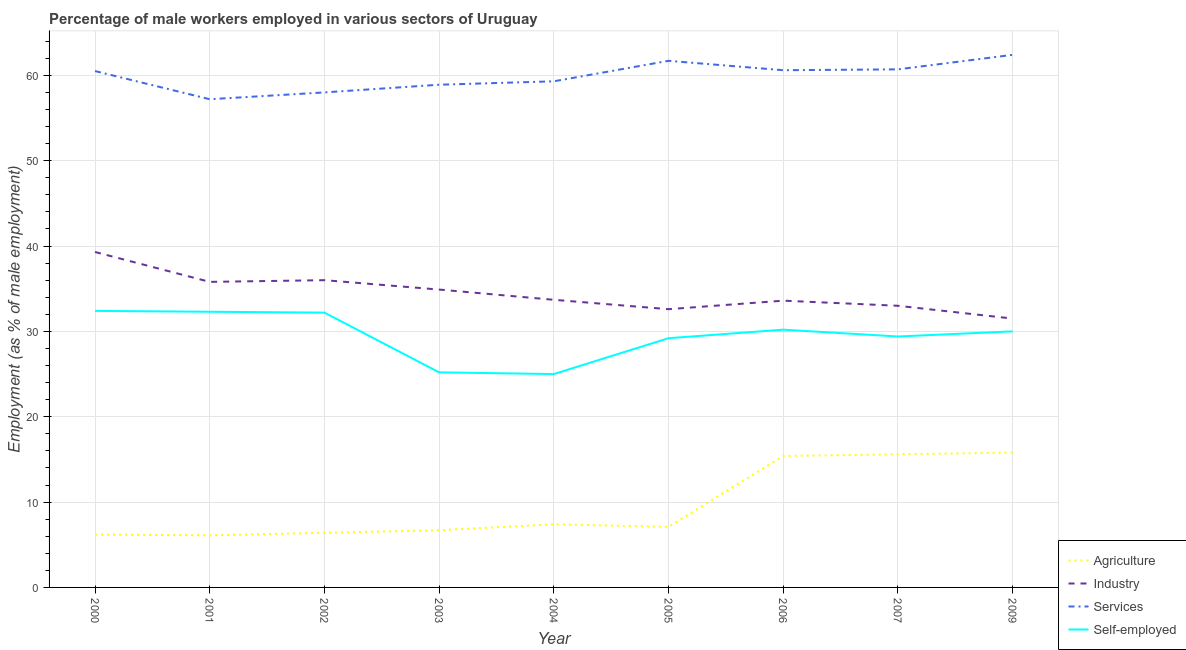Does the line corresponding to percentage of male workers in industry intersect with the line corresponding to percentage of male workers in agriculture?
Your response must be concise. No. Is the number of lines equal to the number of legend labels?
Make the answer very short. Yes. What is the percentage of male workers in services in 2001?
Keep it short and to the point. 57.2. Across all years, what is the maximum percentage of self employed male workers?
Offer a very short reply. 32.4. Across all years, what is the minimum percentage of male workers in services?
Keep it short and to the point. 57.2. In which year was the percentage of self employed male workers minimum?
Your answer should be compact. 2004. What is the total percentage of self employed male workers in the graph?
Offer a very short reply. 265.9. What is the difference between the percentage of self employed male workers in 2001 and that in 2003?
Give a very brief answer. 7.1. What is the difference between the percentage of self employed male workers in 2000 and the percentage of male workers in industry in 2004?
Offer a terse response. -1.3. What is the average percentage of male workers in agriculture per year?
Your answer should be compact. 9.63. In the year 2006, what is the difference between the percentage of self employed male workers and percentage of male workers in agriculture?
Make the answer very short. 14.8. In how many years, is the percentage of male workers in services greater than 30 %?
Give a very brief answer. 9. What is the ratio of the percentage of male workers in services in 2003 to that in 2009?
Provide a short and direct response. 0.94. Is the percentage of self employed male workers in 2002 less than that in 2006?
Provide a short and direct response. No. What is the difference between the highest and the second highest percentage of male workers in industry?
Your answer should be very brief. 3.3. What is the difference between the highest and the lowest percentage of male workers in industry?
Provide a succinct answer. 7.8. In how many years, is the percentage of male workers in industry greater than the average percentage of male workers in industry taken over all years?
Provide a short and direct response. 4. Is it the case that in every year, the sum of the percentage of male workers in agriculture and percentage of male workers in industry is greater than the percentage of male workers in services?
Your response must be concise. No. Does the percentage of male workers in agriculture monotonically increase over the years?
Your answer should be compact. No. Is the percentage of self employed male workers strictly greater than the percentage of male workers in services over the years?
Your response must be concise. No. Is the percentage of male workers in agriculture strictly less than the percentage of male workers in industry over the years?
Keep it short and to the point. Yes. Are the values on the major ticks of Y-axis written in scientific E-notation?
Give a very brief answer. No. Does the graph contain any zero values?
Your answer should be very brief. No. Does the graph contain grids?
Your answer should be compact. Yes. Where does the legend appear in the graph?
Offer a terse response. Bottom right. How many legend labels are there?
Give a very brief answer. 4. What is the title of the graph?
Offer a terse response. Percentage of male workers employed in various sectors of Uruguay. What is the label or title of the X-axis?
Your answer should be compact. Year. What is the label or title of the Y-axis?
Offer a terse response. Employment (as % of male employment). What is the Employment (as % of male employment) in Agriculture in 2000?
Offer a terse response. 6.2. What is the Employment (as % of male employment) in Industry in 2000?
Keep it short and to the point. 39.3. What is the Employment (as % of male employment) of Services in 2000?
Offer a terse response. 60.5. What is the Employment (as % of male employment) in Self-employed in 2000?
Your response must be concise. 32.4. What is the Employment (as % of male employment) of Agriculture in 2001?
Provide a short and direct response. 6.1. What is the Employment (as % of male employment) in Industry in 2001?
Give a very brief answer. 35.8. What is the Employment (as % of male employment) of Services in 2001?
Provide a succinct answer. 57.2. What is the Employment (as % of male employment) of Self-employed in 2001?
Offer a terse response. 32.3. What is the Employment (as % of male employment) in Agriculture in 2002?
Make the answer very short. 6.4. What is the Employment (as % of male employment) in Industry in 2002?
Keep it short and to the point. 36. What is the Employment (as % of male employment) in Self-employed in 2002?
Provide a succinct answer. 32.2. What is the Employment (as % of male employment) in Agriculture in 2003?
Keep it short and to the point. 6.7. What is the Employment (as % of male employment) in Industry in 2003?
Your answer should be compact. 34.9. What is the Employment (as % of male employment) in Services in 2003?
Provide a succinct answer. 58.9. What is the Employment (as % of male employment) of Self-employed in 2003?
Your response must be concise. 25.2. What is the Employment (as % of male employment) in Agriculture in 2004?
Provide a succinct answer. 7.4. What is the Employment (as % of male employment) in Industry in 2004?
Your answer should be compact. 33.7. What is the Employment (as % of male employment) of Services in 2004?
Provide a short and direct response. 59.3. What is the Employment (as % of male employment) of Agriculture in 2005?
Give a very brief answer. 7.1. What is the Employment (as % of male employment) in Industry in 2005?
Your response must be concise. 32.6. What is the Employment (as % of male employment) of Services in 2005?
Provide a succinct answer. 61.7. What is the Employment (as % of male employment) in Self-employed in 2005?
Your answer should be compact. 29.2. What is the Employment (as % of male employment) in Agriculture in 2006?
Your answer should be compact. 15.4. What is the Employment (as % of male employment) of Industry in 2006?
Offer a terse response. 33.6. What is the Employment (as % of male employment) in Services in 2006?
Provide a short and direct response. 60.6. What is the Employment (as % of male employment) in Self-employed in 2006?
Your response must be concise. 30.2. What is the Employment (as % of male employment) of Agriculture in 2007?
Provide a short and direct response. 15.6. What is the Employment (as % of male employment) of Services in 2007?
Your answer should be very brief. 60.7. What is the Employment (as % of male employment) of Self-employed in 2007?
Make the answer very short. 29.4. What is the Employment (as % of male employment) of Agriculture in 2009?
Give a very brief answer. 15.8. What is the Employment (as % of male employment) in Industry in 2009?
Offer a very short reply. 31.5. What is the Employment (as % of male employment) in Services in 2009?
Make the answer very short. 62.4. What is the Employment (as % of male employment) of Self-employed in 2009?
Make the answer very short. 30. Across all years, what is the maximum Employment (as % of male employment) of Agriculture?
Make the answer very short. 15.8. Across all years, what is the maximum Employment (as % of male employment) in Industry?
Provide a short and direct response. 39.3. Across all years, what is the maximum Employment (as % of male employment) in Services?
Offer a terse response. 62.4. Across all years, what is the maximum Employment (as % of male employment) in Self-employed?
Ensure brevity in your answer.  32.4. Across all years, what is the minimum Employment (as % of male employment) in Agriculture?
Your response must be concise. 6.1. Across all years, what is the minimum Employment (as % of male employment) in Industry?
Your response must be concise. 31.5. Across all years, what is the minimum Employment (as % of male employment) of Services?
Ensure brevity in your answer.  57.2. What is the total Employment (as % of male employment) of Agriculture in the graph?
Give a very brief answer. 86.7. What is the total Employment (as % of male employment) of Industry in the graph?
Make the answer very short. 310.4. What is the total Employment (as % of male employment) of Services in the graph?
Provide a short and direct response. 539.3. What is the total Employment (as % of male employment) of Self-employed in the graph?
Your answer should be very brief. 265.9. What is the difference between the Employment (as % of male employment) of Agriculture in 2000 and that in 2001?
Offer a very short reply. 0.1. What is the difference between the Employment (as % of male employment) of Self-employed in 2000 and that in 2001?
Offer a very short reply. 0.1. What is the difference between the Employment (as % of male employment) in Services in 2000 and that in 2002?
Offer a terse response. 2.5. What is the difference between the Employment (as % of male employment) of Self-employed in 2000 and that in 2002?
Give a very brief answer. 0.2. What is the difference between the Employment (as % of male employment) of Agriculture in 2000 and that in 2003?
Your answer should be very brief. -0.5. What is the difference between the Employment (as % of male employment) of Industry in 2000 and that in 2003?
Offer a very short reply. 4.4. What is the difference between the Employment (as % of male employment) of Self-employed in 2000 and that in 2003?
Your answer should be very brief. 7.2. What is the difference between the Employment (as % of male employment) in Services in 2000 and that in 2004?
Make the answer very short. 1.2. What is the difference between the Employment (as % of male employment) in Agriculture in 2000 and that in 2005?
Ensure brevity in your answer.  -0.9. What is the difference between the Employment (as % of male employment) in Industry in 2000 and that in 2005?
Give a very brief answer. 6.7. What is the difference between the Employment (as % of male employment) of Services in 2000 and that in 2005?
Your answer should be compact. -1.2. What is the difference between the Employment (as % of male employment) in Self-employed in 2000 and that in 2005?
Provide a succinct answer. 3.2. What is the difference between the Employment (as % of male employment) of Services in 2000 and that in 2006?
Make the answer very short. -0.1. What is the difference between the Employment (as % of male employment) of Self-employed in 2000 and that in 2006?
Your answer should be compact. 2.2. What is the difference between the Employment (as % of male employment) of Agriculture in 2000 and that in 2007?
Offer a terse response. -9.4. What is the difference between the Employment (as % of male employment) of Services in 2000 and that in 2007?
Provide a succinct answer. -0.2. What is the difference between the Employment (as % of male employment) in Self-employed in 2000 and that in 2007?
Your response must be concise. 3. What is the difference between the Employment (as % of male employment) in Agriculture in 2000 and that in 2009?
Ensure brevity in your answer.  -9.6. What is the difference between the Employment (as % of male employment) in Industry in 2000 and that in 2009?
Your answer should be very brief. 7.8. What is the difference between the Employment (as % of male employment) in Services in 2000 and that in 2009?
Your answer should be compact. -1.9. What is the difference between the Employment (as % of male employment) of Self-employed in 2000 and that in 2009?
Your answer should be compact. 2.4. What is the difference between the Employment (as % of male employment) in Agriculture in 2001 and that in 2002?
Offer a terse response. -0.3. What is the difference between the Employment (as % of male employment) in Services in 2001 and that in 2002?
Your answer should be very brief. -0.8. What is the difference between the Employment (as % of male employment) in Agriculture in 2001 and that in 2003?
Offer a very short reply. -0.6. What is the difference between the Employment (as % of male employment) in Industry in 2001 and that in 2003?
Keep it short and to the point. 0.9. What is the difference between the Employment (as % of male employment) in Services in 2001 and that in 2003?
Ensure brevity in your answer.  -1.7. What is the difference between the Employment (as % of male employment) in Services in 2001 and that in 2005?
Make the answer very short. -4.5. What is the difference between the Employment (as % of male employment) in Agriculture in 2001 and that in 2006?
Your answer should be compact. -9.3. What is the difference between the Employment (as % of male employment) of Agriculture in 2001 and that in 2007?
Provide a short and direct response. -9.5. What is the difference between the Employment (as % of male employment) in Industry in 2001 and that in 2007?
Keep it short and to the point. 2.8. What is the difference between the Employment (as % of male employment) of Services in 2001 and that in 2007?
Make the answer very short. -3.5. What is the difference between the Employment (as % of male employment) in Self-employed in 2001 and that in 2007?
Make the answer very short. 2.9. What is the difference between the Employment (as % of male employment) in Industry in 2001 and that in 2009?
Ensure brevity in your answer.  4.3. What is the difference between the Employment (as % of male employment) of Self-employed in 2002 and that in 2003?
Your answer should be compact. 7. What is the difference between the Employment (as % of male employment) of Industry in 2002 and that in 2004?
Offer a very short reply. 2.3. What is the difference between the Employment (as % of male employment) of Self-employed in 2002 and that in 2004?
Make the answer very short. 7.2. What is the difference between the Employment (as % of male employment) of Agriculture in 2002 and that in 2005?
Offer a very short reply. -0.7. What is the difference between the Employment (as % of male employment) of Industry in 2002 and that in 2005?
Give a very brief answer. 3.4. What is the difference between the Employment (as % of male employment) in Self-employed in 2002 and that in 2005?
Give a very brief answer. 3. What is the difference between the Employment (as % of male employment) in Agriculture in 2002 and that in 2006?
Give a very brief answer. -9. What is the difference between the Employment (as % of male employment) in Industry in 2002 and that in 2006?
Your response must be concise. 2.4. What is the difference between the Employment (as % of male employment) in Self-employed in 2002 and that in 2006?
Ensure brevity in your answer.  2. What is the difference between the Employment (as % of male employment) of Agriculture in 2002 and that in 2007?
Your answer should be compact. -9.2. What is the difference between the Employment (as % of male employment) of Industry in 2002 and that in 2007?
Offer a terse response. 3. What is the difference between the Employment (as % of male employment) of Services in 2002 and that in 2007?
Make the answer very short. -2.7. What is the difference between the Employment (as % of male employment) in Industry in 2002 and that in 2009?
Make the answer very short. 4.5. What is the difference between the Employment (as % of male employment) in Self-employed in 2002 and that in 2009?
Your response must be concise. 2.2. What is the difference between the Employment (as % of male employment) of Agriculture in 2003 and that in 2004?
Your answer should be very brief. -0.7. What is the difference between the Employment (as % of male employment) in Industry in 2003 and that in 2004?
Offer a terse response. 1.2. What is the difference between the Employment (as % of male employment) in Self-employed in 2003 and that in 2004?
Give a very brief answer. 0.2. What is the difference between the Employment (as % of male employment) in Industry in 2003 and that in 2005?
Offer a terse response. 2.3. What is the difference between the Employment (as % of male employment) of Self-employed in 2003 and that in 2005?
Offer a very short reply. -4. What is the difference between the Employment (as % of male employment) in Agriculture in 2003 and that in 2006?
Ensure brevity in your answer.  -8.7. What is the difference between the Employment (as % of male employment) of Industry in 2003 and that in 2006?
Make the answer very short. 1.3. What is the difference between the Employment (as % of male employment) of Services in 2003 and that in 2006?
Provide a succinct answer. -1.7. What is the difference between the Employment (as % of male employment) of Industry in 2003 and that in 2007?
Your answer should be compact. 1.9. What is the difference between the Employment (as % of male employment) in Self-employed in 2003 and that in 2009?
Provide a succinct answer. -4.8. What is the difference between the Employment (as % of male employment) in Agriculture in 2004 and that in 2005?
Offer a terse response. 0.3. What is the difference between the Employment (as % of male employment) in Industry in 2004 and that in 2005?
Offer a terse response. 1.1. What is the difference between the Employment (as % of male employment) in Services in 2004 and that in 2005?
Your response must be concise. -2.4. What is the difference between the Employment (as % of male employment) of Agriculture in 2004 and that in 2006?
Offer a terse response. -8. What is the difference between the Employment (as % of male employment) in Self-employed in 2004 and that in 2006?
Offer a very short reply. -5.2. What is the difference between the Employment (as % of male employment) in Industry in 2004 and that in 2007?
Offer a very short reply. 0.7. What is the difference between the Employment (as % of male employment) of Services in 2004 and that in 2007?
Provide a short and direct response. -1.4. What is the difference between the Employment (as % of male employment) in Services in 2004 and that in 2009?
Provide a short and direct response. -3.1. What is the difference between the Employment (as % of male employment) in Self-employed in 2004 and that in 2009?
Provide a short and direct response. -5. What is the difference between the Employment (as % of male employment) of Industry in 2005 and that in 2006?
Ensure brevity in your answer.  -1. What is the difference between the Employment (as % of male employment) of Services in 2005 and that in 2006?
Offer a terse response. 1.1. What is the difference between the Employment (as % of male employment) in Self-employed in 2005 and that in 2006?
Give a very brief answer. -1. What is the difference between the Employment (as % of male employment) of Agriculture in 2005 and that in 2007?
Ensure brevity in your answer.  -8.5. What is the difference between the Employment (as % of male employment) in Industry in 2005 and that in 2007?
Keep it short and to the point. -0.4. What is the difference between the Employment (as % of male employment) of Services in 2005 and that in 2009?
Your response must be concise. -0.7. What is the difference between the Employment (as % of male employment) of Self-employed in 2005 and that in 2009?
Give a very brief answer. -0.8. What is the difference between the Employment (as % of male employment) in Agriculture in 2006 and that in 2009?
Keep it short and to the point. -0.4. What is the difference between the Employment (as % of male employment) of Industry in 2006 and that in 2009?
Provide a succinct answer. 2.1. What is the difference between the Employment (as % of male employment) of Services in 2006 and that in 2009?
Make the answer very short. -1.8. What is the difference between the Employment (as % of male employment) in Industry in 2007 and that in 2009?
Provide a succinct answer. 1.5. What is the difference between the Employment (as % of male employment) in Self-employed in 2007 and that in 2009?
Ensure brevity in your answer.  -0.6. What is the difference between the Employment (as % of male employment) of Agriculture in 2000 and the Employment (as % of male employment) of Industry in 2001?
Your answer should be very brief. -29.6. What is the difference between the Employment (as % of male employment) in Agriculture in 2000 and the Employment (as % of male employment) in Services in 2001?
Provide a short and direct response. -51. What is the difference between the Employment (as % of male employment) in Agriculture in 2000 and the Employment (as % of male employment) in Self-employed in 2001?
Your answer should be compact. -26.1. What is the difference between the Employment (as % of male employment) in Industry in 2000 and the Employment (as % of male employment) in Services in 2001?
Offer a terse response. -17.9. What is the difference between the Employment (as % of male employment) in Services in 2000 and the Employment (as % of male employment) in Self-employed in 2001?
Provide a succinct answer. 28.2. What is the difference between the Employment (as % of male employment) of Agriculture in 2000 and the Employment (as % of male employment) of Industry in 2002?
Provide a short and direct response. -29.8. What is the difference between the Employment (as % of male employment) of Agriculture in 2000 and the Employment (as % of male employment) of Services in 2002?
Keep it short and to the point. -51.8. What is the difference between the Employment (as % of male employment) of Agriculture in 2000 and the Employment (as % of male employment) of Self-employed in 2002?
Provide a short and direct response. -26. What is the difference between the Employment (as % of male employment) of Industry in 2000 and the Employment (as % of male employment) of Services in 2002?
Offer a terse response. -18.7. What is the difference between the Employment (as % of male employment) in Services in 2000 and the Employment (as % of male employment) in Self-employed in 2002?
Ensure brevity in your answer.  28.3. What is the difference between the Employment (as % of male employment) in Agriculture in 2000 and the Employment (as % of male employment) in Industry in 2003?
Your response must be concise. -28.7. What is the difference between the Employment (as % of male employment) of Agriculture in 2000 and the Employment (as % of male employment) of Services in 2003?
Ensure brevity in your answer.  -52.7. What is the difference between the Employment (as % of male employment) in Industry in 2000 and the Employment (as % of male employment) in Services in 2003?
Your answer should be compact. -19.6. What is the difference between the Employment (as % of male employment) of Services in 2000 and the Employment (as % of male employment) of Self-employed in 2003?
Provide a succinct answer. 35.3. What is the difference between the Employment (as % of male employment) in Agriculture in 2000 and the Employment (as % of male employment) in Industry in 2004?
Give a very brief answer. -27.5. What is the difference between the Employment (as % of male employment) in Agriculture in 2000 and the Employment (as % of male employment) in Services in 2004?
Make the answer very short. -53.1. What is the difference between the Employment (as % of male employment) of Agriculture in 2000 and the Employment (as % of male employment) of Self-employed in 2004?
Your answer should be compact. -18.8. What is the difference between the Employment (as % of male employment) of Industry in 2000 and the Employment (as % of male employment) of Services in 2004?
Offer a very short reply. -20. What is the difference between the Employment (as % of male employment) of Industry in 2000 and the Employment (as % of male employment) of Self-employed in 2004?
Provide a succinct answer. 14.3. What is the difference between the Employment (as % of male employment) of Services in 2000 and the Employment (as % of male employment) of Self-employed in 2004?
Keep it short and to the point. 35.5. What is the difference between the Employment (as % of male employment) of Agriculture in 2000 and the Employment (as % of male employment) of Industry in 2005?
Keep it short and to the point. -26.4. What is the difference between the Employment (as % of male employment) in Agriculture in 2000 and the Employment (as % of male employment) in Services in 2005?
Your answer should be very brief. -55.5. What is the difference between the Employment (as % of male employment) of Agriculture in 2000 and the Employment (as % of male employment) of Self-employed in 2005?
Offer a very short reply. -23. What is the difference between the Employment (as % of male employment) in Industry in 2000 and the Employment (as % of male employment) in Services in 2005?
Offer a terse response. -22.4. What is the difference between the Employment (as % of male employment) in Services in 2000 and the Employment (as % of male employment) in Self-employed in 2005?
Offer a terse response. 31.3. What is the difference between the Employment (as % of male employment) of Agriculture in 2000 and the Employment (as % of male employment) of Industry in 2006?
Make the answer very short. -27.4. What is the difference between the Employment (as % of male employment) of Agriculture in 2000 and the Employment (as % of male employment) of Services in 2006?
Ensure brevity in your answer.  -54.4. What is the difference between the Employment (as % of male employment) of Industry in 2000 and the Employment (as % of male employment) of Services in 2006?
Your answer should be very brief. -21.3. What is the difference between the Employment (as % of male employment) of Services in 2000 and the Employment (as % of male employment) of Self-employed in 2006?
Provide a succinct answer. 30.3. What is the difference between the Employment (as % of male employment) of Agriculture in 2000 and the Employment (as % of male employment) of Industry in 2007?
Ensure brevity in your answer.  -26.8. What is the difference between the Employment (as % of male employment) in Agriculture in 2000 and the Employment (as % of male employment) in Services in 2007?
Offer a terse response. -54.5. What is the difference between the Employment (as % of male employment) in Agriculture in 2000 and the Employment (as % of male employment) in Self-employed in 2007?
Make the answer very short. -23.2. What is the difference between the Employment (as % of male employment) of Industry in 2000 and the Employment (as % of male employment) of Services in 2007?
Offer a very short reply. -21.4. What is the difference between the Employment (as % of male employment) in Services in 2000 and the Employment (as % of male employment) in Self-employed in 2007?
Offer a very short reply. 31.1. What is the difference between the Employment (as % of male employment) in Agriculture in 2000 and the Employment (as % of male employment) in Industry in 2009?
Make the answer very short. -25.3. What is the difference between the Employment (as % of male employment) of Agriculture in 2000 and the Employment (as % of male employment) of Services in 2009?
Keep it short and to the point. -56.2. What is the difference between the Employment (as % of male employment) in Agriculture in 2000 and the Employment (as % of male employment) in Self-employed in 2009?
Give a very brief answer. -23.8. What is the difference between the Employment (as % of male employment) in Industry in 2000 and the Employment (as % of male employment) in Services in 2009?
Your response must be concise. -23.1. What is the difference between the Employment (as % of male employment) in Services in 2000 and the Employment (as % of male employment) in Self-employed in 2009?
Keep it short and to the point. 30.5. What is the difference between the Employment (as % of male employment) of Agriculture in 2001 and the Employment (as % of male employment) of Industry in 2002?
Provide a short and direct response. -29.9. What is the difference between the Employment (as % of male employment) in Agriculture in 2001 and the Employment (as % of male employment) in Services in 2002?
Your answer should be very brief. -51.9. What is the difference between the Employment (as % of male employment) of Agriculture in 2001 and the Employment (as % of male employment) of Self-employed in 2002?
Ensure brevity in your answer.  -26.1. What is the difference between the Employment (as % of male employment) in Industry in 2001 and the Employment (as % of male employment) in Services in 2002?
Offer a very short reply. -22.2. What is the difference between the Employment (as % of male employment) of Services in 2001 and the Employment (as % of male employment) of Self-employed in 2002?
Your response must be concise. 25. What is the difference between the Employment (as % of male employment) in Agriculture in 2001 and the Employment (as % of male employment) in Industry in 2003?
Keep it short and to the point. -28.8. What is the difference between the Employment (as % of male employment) of Agriculture in 2001 and the Employment (as % of male employment) of Services in 2003?
Make the answer very short. -52.8. What is the difference between the Employment (as % of male employment) in Agriculture in 2001 and the Employment (as % of male employment) in Self-employed in 2003?
Offer a terse response. -19.1. What is the difference between the Employment (as % of male employment) of Industry in 2001 and the Employment (as % of male employment) of Services in 2003?
Make the answer very short. -23.1. What is the difference between the Employment (as % of male employment) of Industry in 2001 and the Employment (as % of male employment) of Self-employed in 2003?
Your response must be concise. 10.6. What is the difference between the Employment (as % of male employment) in Agriculture in 2001 and the Employment (as % of male employment) in Industry in 2004?
Offer a terse response. -27.6. What is the difference between the Employment (as % of male employment) of Agriculture in 2001 and the Employment (as % of male employment) of Services in 2004?
Your answer should be compact. -53.2. What is the difference between the Employment (as % of male employment) in Agriculture in 2001 and the Employment (as % of male employment) in Self-employed in 2004?
Offer a terse response. -18.9. What is the difference between the Employment (as % of male employment) of Industry in 2001 and the Employment (as % of male employment) of Services in 2004?
Ensure brevity in your answer.  -23.5. What is the difference between the Employment (as % of male employment) in Services in 2001 and the Employment (as % of male employment) in Self-employed in 2004?
Your answer should be very brief. 32.2. What is the difference between the Employment (as % of male employment) of Agriculture in 2001 and the Employment (as % of male employment) of Industry in 2005?
Provide a short and direct response. -26.5. What is the difference between the Employment (as % of male employment) of Agriculture in 2001 and the Employment (as % of male employment) of Services in 2005?
Your answer should be very brief. -55.6. What is the difference between the Employment (as % of male employment) of Agriculture in 2001 and the Employment (as % of male employment) of Self-employed in 2005?
Offer a terse response. -23.1. What is the difference between the Employment (as % of male employment) in Industry in 2001 and the Employment (as % of male employment) in Services in 2005?
Offer a very short reply. -25.9. What is the difference between the Employment (as % of male employment) of Services in 2001 and the Employment (as % of male employment) of Self-employed in 2005?
Offer a very short reply. 28. What is the difference between the Employment (as % of male employment) of Agriculture in 2001 and the Employment (as % of male employment) of Industry in 2006?
Give a very brief answer. -27.5. What is the difference between the Employment (as % of male employment) of Agriculture in 2001 and the Employment (as % of male employment) of Services in 2006?
Keep it short and to the point. -54.5. What is the difference between the Employment (as % of male employment) in Agriculture in 2001 and the Employment (as % of male employment) in Self-employed in 2006?
Your answer should be very brief. -24.1. What is the difference between the Employment (as % of male employment) in Industry in 2001 and the Employment (as % of male employment) in Services in 2006?
Offer a very short reply. -24.8. What is the difference between the Employment (as % of male employment) in Services in 2001 and the Employment (as % of male employment) in Self-employed in 2006?
Offer a terse response. 27. What is the difference between the Employment (as % of male employment) in Agriculture in 2001 and the Employment (as % of male employment) in Industry in 2007?
Your answer should be compact. -26.9. What is the difference between the Employment (as % of male employment) in Agriculture in 2001 and the Employment (as % of male employment) in Services in 2007?
Provide a short and direct response. -54.6. What is the difference between the Employment (as % of male employment) in Agriculture in 2001 and the Employment (as % of male employment) in Self-employed in 2007?
Your answer should be compact. -23.3. What is the difference between the Employment (as % of male employment) in Industry in 2001 and the Employment (as % of male employment) in Services in 2007?
Give a very brief answer. -24.9. What is the difference between the Employment (as % of male employment) in Industry in 2001 and the Employment (as % of male employment) in Self-employed in 2007?
Make the answer very short. 6.4. What is the difference between the Employment (as % of male employment) in Services in 2001 and the Employment (as % of male employment) in Self-employed in 2007?
Offer a terse response. 27.8. What is the difference between the Employment (as % of male employment) of Agriculture in 2001 and the Employment (as % of male employment) of Industry in 2009?
Your response must be concise. -25.4. What is the difference between the Employment (as % of male employment) of Agriculture in 2001 and the Employment (as % of male employment) of Services in 2009?
Keep it short and to the point. -56.3. What is the difference between the Employment (as % of male employment) of Agriculture in 2001 and the Employment (as % of male employment) of Self-employed in 2009?
Keep it short and to the point. -23.9. What is the difference between the Employment (as % of male employment) of Industry in 2001 and the Employment (as % of male employment) of Services in 2009?
Your response must be concise. -26.6. What is the difference between the Employment (as % of male employment) in Industry in 2001 and the Employment (as % of male employment) in Self-employed in 2009?
Provide a short and direct response. 5.8. What is the difference between the Employment (as % of male employment) of Services in 2001 and the Employment (as % of male employment) of Self-employed in 2009?
Give a very brief answer. 27.2. What is the difference between the Employment (as % of male employment) in Agriculture in 2002 and the Employment (as % of male employment) in Industry in 2003?
Ensure brevity in your answer.  -28.5. What is the difference between the Employment (as % of male employment) in Agriculture in 2002 and the Employment (as % of male employment) in Services in 2003?
Your answer should be compact. -52.5. What is the difference between the Employment (as % of male employment) in Agriculture in 2002 and the Employment (as % of male employment) in Self-employed in 2003?
Provide a short and direct response. -18.8. What is the difference between the Employment (as % of male employment) of Industry in 2002 and the Employment (as % of male employment) of Services in 2003?
Ensure brevity in your answer.  -22.9. What is the difference between the Employment (as % of male employment) in Services in 2002 and the Employment (as % of male employment) in Self-employed in 2003?
Provide a short and direct response. 32.8. What is the difference between the Employment (as % of male employment) in Agriculture in 2002 and the Employment (as % of male employment) in Industry in 2004?
Your answer should be compact. -27.3. What is the difference between the Employment (as % of male employment) of Agriculture in 2002 and the Employment (as % of male employment) of Services in 2004?
Keep it short and to the point. -52.9. What is the difference between the Employment (as % of male employment) in Agriculture in 2002 and the Employment (as % of male employment) in Self-employed in 2004?
Offer a terse response. -18.6. What is the difference between the Employment (as % of male employment) in Industry in 2002 and the Employment (as % of male employment) in Services in 2004?
Ensure brevity in your answer.  -23.3. What is the difference between the Employment (as % of male employment) of Services in 2002 and the Employment (as % of male employment) of Self-employed in 2004?
Give a very brief answer. 33. What is the difference between the Employment (as % of male employment) in Agriculture in 2002 and the Employment (as % of male employment) in Industry in 2005?
Provide a short and direct response. -26.2. What is the difference between the Employment (as % of male employment) in Agriculture in 2002 and the Employment (as % of male employment) in Services in 2005?
Your answer should be compact. -55.3. What is the difference between the Employment (as % of male employment) of Agriculture in 2002 and the Employment (as % of male employment) of Self-employed in 2005?
Give a very brief answer. -22.8. What is the difference between the Employment (as % of male employment) of Industry in 2002 and the Employment (as % of male employment) of Services in 2005?
Keep it short and to the point. -25.7. What is the difference between the Employment (as % of male employment) in Services in 2002 and the Employment (as % of male employment) in Self-employed in 2005?
Make the answer very short. 28.8. What is the difference between the Employment (as % of male employment) in Agriculture in 2002 and the Employment (as % of male employment) in Industry in 2006?
Offer a terse response. -27.2. What is the difference between the Employment (as % of male employment) of Agriculture in 2002 and the Employment (as % of male employment) of Services in 2006?
Your answer should be very brief. -54.2. What is the difference between the Employment (as % of male employment) in Agriculture in 2002 and the Employment (as % of male employment) in Self-employed in 2006?
Offer a terse response. -23.8. What is the difference between the Employment (as % of male employment) in Industry in 2002 and the Employment (as % of male employment) in Services in 2006?
Your answer should be very brief. -24.6. What is the difference between the Employment (as % of male employment) in Services in 2002 and the Employment (as % of male employment) in Self-employed in 2006?
Keep it short and to the point. 27.8. What is the difference between the Employment (as % of male employment) of Agriculture in 2002 and the Employment (as % of male employment) of Industry in 2007?
Ensure brevity in your answer.  -26.6. What is the difference between the Employment (as % of male employment) of Agriculture in 2002 and the Employment (as % of male employment) of Services in 2007?
Ensure brevity in your answer.  -54.3. What is the difference between the Employment (as % of male employment) of Agriculture in 2002 and the Employment (as % of male employment) of Self-employed in 2007?
Make the answer very short. -23. What is the difference between the Employment (as % of male employment) in Industry in 2002 and the Employment (as % of male employment) in Services in 2007?
Your answer should be compact. -24.7. What is the difference between the Employment (as % of male employment) in Services in 2002 and the Employment (as % of male employment) in Self-employed in 2007?
Provide a short and direct response. 28.6. What is the difference between the Employment (as % of male employment) in Agriculture in 2002 and the Employment (as % of male employment) in Industry in 2009?
Offer a very short reply. -25.1. What is the difference between the Employment (as % of male employment) in Agriculture in 2002 and the Employment (as % of male employment) in Services in 2009?
Offer a terse response. -56. What is the difference between the Employment (as % of male employment) of Agriculture in 2002 and the Employment (as % of male employment) of Self-employed in 2009?
Give a very brief answer. -23.6. What is the difference between the Employment (as % of male employment) of Industry in 2002 and the Employment (as % of male employment) of Services in 2009?
Offer a very short reply. -26.4. What is the difference between the Employment (as % of male employment) of Industry in 2002 and the Employment (as % of male employment) of Self-employed in 2009?
Ensure brevity in your answer.  6. What is the difference between the Employment (as % of male employment) of Agriculture in 2003 and the Employment (as % of male employment) of Industry in 2004?
Make the answer very short. -27. What is the difference between the Employment (as % of male employment) in Agriculture in 2003 and the Employment (as % of male employment) in Services in 2004?
Give a very brief answer. -52.6. What is the difference between the Employment (as % of male employment) of Agriculture in 2003 and the Employment (as % of male employment) of Self-employed in 2004?
Provide a succinct answer. -18.3. What is the difference between the Employment (as % of male employment) of Industry in 2003 and the Employment (as % of male employment) of Services in 2004?
Offer a very short reply. -24.4. What is the difference between the Employment (as % of male employment) in Services in 2003 and the Employment (as % of male employment) in Self-employed in 2004?
Keep it short and to the point. 33.9. What is the difference between the Employment (as % of male employment) of Agriculture in 2003 and the Employment (as % of male employment) of Industry in 2005?
Ensure brevity in your answer.  -25.9. What is the difference between the Employment (as % of male employment) of Agriculture in 2003 and the Employment (as % of male employment) of Services in 2005?
Your answer should be compact. -55. What is the difference between the Employment (as % of male employment) in Agriculture in 2003 and the Employment (as % of male employment) in Self-employed in 2005?
Give a very brief answer. -22.5. What is the difference between the Employment (as % of male employment) of Industry in 2003 and the Employment (as % of male employment) of Services in 2005?
Offer a very short reply. -26.8. What is the difference between the Employment (as % of male employment) in Industry in 2003 and the Employment (as % of male employment) in Self-employed in 2005?
Provide a short and direct response. 5.7. What is the difference between the Employment (as % of male employment) of Services in 2003 and the Employment (as % of male employment) of Self-employed in 2005?
Provide a succinct answer. 29.7. What is the difference between the Employment (as % of male employment) of Agriculture in 2003 and the Employment (as % of male employment) of Industry in 2006?
Your answer should be compact. -26.9. What is the difference between the Employment (as % of male employment) in Agriculture in 2003 and the Employment (as % of male employment) in Services in 2006?
Provide a succinct answer. -53.9. What is the difference between the Employment (as % of male employment) in Agriculture in 2003 and the Employment (as % of male employment) in Self-employed in 2006?
Your answer should be very brief. -23.5. What is the difference between the Employment (as % of male employment) of Industry in 2003 and the Employment (as % of male employment) of Services in 2006?
Keep it short and to the point. -25.7. What is the difference between the Employment (as % of male employment) of Industry in 2003 and the Employment (as % of male employment) of Self-employed in 2006?
Offer a terse response. 4.7. What is the difference between the Employment (as % of male employment) of Services in 2003 and the Employment (as % of male employment) of Self-employed in 2006?
Your answer should be very brief. 28.7. What is the difference between the Employment (as % of male employment) in Agriculture in 2003 and the Employment (as % of male employment) in Industry in 2007?
Give a very brief answer. -26.3. What is the difference between the Employment (as % of male employment) of Agriculture in 2003 and the Employment (as % of male employment) of Services in 2007?
Your response must be concise. -54. What is the difference between the Employment (as % of male employment) of Agriculture in 2003 and the Employment (as % of male employment) of Self-employed in 2007?
Offer a terse response. -22.7. What is the difference between the Employment (as % of male employment) in Industry in 2003 and the Employment (as % of male employment) in Services in 2007?
Make the answer very short. -25.8. What is the difference between the Employment (as % of male employment) in Services in 2003 and the Employment (as % of male employment) in Self-employed in 2007?
Keep it short and to the point. 29.5. What is the difference between the Employment (as % of male employment) of Agriculture in 2003 and the Employment (as % of male employment) of Industry in 2009?
Give a very brief answer. -24.8. What is the difference between the Employment (as % of male employment) of Agriculture in 2003 and the Employment (as % of male employment) of Services in 2009?
Offer a very short reply. -55.7. What is the difference between the Employment (as % of male employment) in Agriculture in 2003 and the Employment (as % of male employment) in Self-employed in 2009?
Your answer should be compact. -23.3. What is the difference between the Employment (as % of male employment) of Industry in 2003 and the Employment (as % of male employment) of Services in 2009?
Provide a succinct answer. -27.5. What is the difference between the Employment (as % of male employment) of Industry in 2003 and the Employment (as % of male employment) of Self-employed in 2009?
Your response must be concise. 4.9. What is the difference between the Employment (as % of male employment) in Services in 2003 and the Employment (as % of male employment) in Self-employed in 2009?
Keep it short and to the point. 28.9. What is the difference between the Employment (as % of male employment) in Agriculture in 2004 and the Employment (as % of male employment) in Industry in 2005?
Keep it short and to the point. -25.2. What is the difference between the Employment (as % of male employment) in Agriculture in 2004 and the Employment (as % of male employment) in Services in 2005?
Provide a succinct answer. -54.3. What is the difference between the Employment (as % of male employment) of Agriculture in 2004 and the Employment (as % of male employment) of Self-employed in 2005?
Make the answer very short. -21.8. What is the difference between the Employment (as % of male employment) in Industry in 2004 and the Employment (as % of male employment) in Self-employed in 2005?
Your response must be concise. 4.5. What is the difference between the Employment (as % of male employment) of Services in 2004 and the Employment (as % of male employment) of Self-employed in 2005?
Provide a short and direct response. 30.1. What is the difference between the Employment (as % of male employment) of Agriculture in 2004 and the Employment (as % of male employment) of Industry in 2006?
Provide a succinct answer. -26.2. What is the difference between the Employment (as % of male employment) of Agriculture in 2004 and the Employment (as % of male employment) of Services in 2006?
Make the answer very short. -53.2. What is the difference between the Employment (as % of male employment) in Agriculture in 2004 and the Employment (as % of male employment) in Self-employed in 2006?
Offer a very short reply. -22.8. What is the difference between the Employment (as % of male employment) of Industry in 2004 and the Employment (as % of male employment) of Services in 2006?
Keep it short and to the point. -26.9. What is the difference between the Employment (as % of male employment) in Industry in 2004 and the Employment (as % of male employment) in Self-employed in 2006?
Ensure brevity in your answer.  3.5. What is the difference between the Employment (as % of male employment) of Services in 2004 and the Employment (as % of male employment) of Self-employed in 2006?
Provide a short and direct response. 29.1. What is the difference between the Employment (as % of male employment) of Agriculture in 2004 and the Employment (as % of male employment) of Industry in 2007?
Your answer should be very brief. -25.6. What is the difference between the Employment (as % of male employment) in Agriculture in 2004 and the Employment (as % of male employment) in Services in 2007?
Provide a short and direct response. -53.3. What is the difference between the Employment (as % of male employment) in Agriculture in 2004 and the Employment (as % of male employment) in Self-employed in 2007?
Provide a short and direct response. -22. What is the difference between the Employment (as % of male employment) in Industry in 2004 and the Employment (as % of male employment) in Services in 2007?
Give a very brief answer. -27. What is the difference between the Employment (as % of male employment) in Industry in 2004 and the Employment (as % of male employment) in Self-employed in 2007?
Offer a terse response. 4.3. What is the difference between the Employment (as % of male employment) in Services in 2004 and the Employment (as % of male employment) in Self-employed in 2007?
Keep it short and to the point. 29.9. What is the difference between the Employment (as % of male employment) in Agriculture in 2004 and the Employment (as % of male employment) in Industry in 2009?
Offer a terse response. -24.1. What is the difference between the Employment (as % of male employment) of Agriculture in 2004 and the Employment (as % of male employment) of Services in 2009?
Provide a succinct answer. -55. What is the difference between the Employment (as % of male employment) of Agriculture in 2004 and the Employment (as % of male employment) of Self-employed in 2009?
Offer a terse response. -22.6. What is the difference between the Employment (as % of male employment) in Industry in 2004 and the Employment (as % of male employment) in Services in 2009?
Make the answer very short. -28.7. What is the difference between the Employment (as % of male employment) of Services in 2004 and the Employment (as % of male employment) of Self-employed in 2009?
Your response must be concise. 29.3. What is the difference between the Employment (as % of male employment) in Agriculture in 2005 and the Employment (as % of male employment) in Industry in 2006?
Make the answer very short. -26.5. What is the difference between the Employment (as % of male employment) in Agriculture in 2005 and the Employment (as % of male employment) in Services in 2006?
Keep it short and to the point. -53.5. What is the difference between the Employment (as % of male employment) in Agriculture in 2005 and the Employment (as % of male employment) in Self-employed in 2006?
Provide a succinct answer. -23.1. What is the difference between the Employment (as % of male employment) of Services in 2005 and the Employment (as % of male employment) of Self-employed in 2006?
Offer a terse response. 31.5. What is the difference between the Employment (as % of male employment) of Agriculture in 2005 and the Employment (as % of male employment) of Industry in 2007?
Your answer should be compact. -25.9. What is the difference between the Employment (as % of male employment) of Agriculture in 2005 and the Employment (as % of male employment) of Services in 2007?
Provide a short and direct response. -53.6. What is the difference between the Employment (as % of male employment) in Agriculture in 2005 and the Employment (as % of male employment) in Self-employed in 2007?
Offer a terse response. -22.3. What is the difference between the Employment (as % of male employment) of Industry in 2005 and the Employment (as % of male employment) of Services in 2007?
Ensure brevity in your answer.  -28.1. What is the difference between the Employment (as % of male employment) of Industry in 2005 and the Employment (as % of male employment) of Self-employed in 2007?
Your answer should be very brief. 3.2. What is the difference between the Employment (as % of male employment) of Services in 2005 and the Employment (as % of male employment) of Self-employed in 2007?
Your response must be concise. 32.3. What is the difference between the Employment (as % of male employment) in Agriculture in 2005 and the Employment (as % of male employment) in Industry in 2009?
Your answer should be compact. -24.4. What is the difference between the Employment (as % of male employment) in Agriculture in 2005 and the Employment (as % of male employment) in Services in 2009?
Provide a short and direct response. -55.3. What is the difference between the Employment (as % of male employment) of Agriculture in 2005 and the Employment (as % of male employment) of Self-employed in 2009?
Your response must be concise. -22.9. What is the difference between the Employment (as % of male employment) in Industry in 2005 and the Employment (as % of male employment) in Services in 2009?
Offer a very short reply. -29.8. What is the difference between the Employment (as % of male employment) of Services in 2005 and the Employment (as % of male employment) of Self-employed in 2009?
Ensure brevity in your answer.  31.7. What is the difference between the Employment (as % of male employment) in Agriculture in 2006 and the Employment (as % of male employment) in Industry in 2007?
Ensure brevity in your answer.  -17.6. What is the difference between the Employment (as % of male employment) of Agriculture in 2006 and the Employment (as % of male employment) of Services in 2007?
Offer a terse response. -45.3. What is the difference between the Employment (as % of male employment) of Agriculture in 2006 and the Employment (as % of male employment) of Self-employed in 2007?
Offer a terse response. -14. What is the difference between the Employment (as % of male employment) in Industry in 2006 and the Employment (as % of male employment) in Services in 2007?
Your response must be concise. -27.1. What is the difference between the Employment (as % of male employment) of Industry in 2006 and the Employment (as % of male employment) of Self-employed in 2007?
Offer a very short reply. 4.2. What is the difference between the Employment (as % of male employment) of Services in 2006 and the Employment (as % of male employment) of Self-employed in 2007?
Your answer should be compact. 31.2. What is the difference between the Employment (as % of male employment) of Agriculture in 2006 and the Employment (as % of male employment) of Industry in 2009?
Give a very brief answer. -16.1. What is the difference between the Employment (as % of male employment) of Agriculture in 2006 and the Employment (as % of male employment) of Services in 2009?
Make the answer very short. -47. What is the difference between the Employment (as % of male employment) in Agriculture in 2006 and the Employment (as % of male employment) in Self-employed in 2009?
Offer a very short reply. -14.6. What is the difference between the Employment (as % of male employment) in Industry in 2006 and the Employment (as % of male employment) in Services in 2009?
Keep it short and to the point. -28.8. What is the difference between the Employment (as % of male employment) of Industry in 2006 and the Employment (as % of male employment) of Self-employed in 2009?
Your answer should be very brief. 3.6. What is the difference between the Employment (as % of male employment) in Services in 2006 and the Employment (as % of male employment) in Self-employed in 2009?
Your answer should be compact. 30.6. What is the difference between the Employment (as % of male employment) of Agriculture in 2007 and the Employment (as % of male employment) of Industry in 2009?
Your answer should be compact. -15.9. What is the difference between the Employment (as % of male employment) of Agriculture in 2007 and the Employment (as % of male employment) of Services in 2009?
Your response must be concise. -46.8. What is the difference between the Employment (as % of male employment) of Agriculture in 2007 and the Employment (as % of male employment) of Self-employed in 2009?
Offer a terse response. -14.4. What is the difference between the Employment (as % of male employment) in Industry in 2007 and the Employment (as % of male employment) in Services in 2009?
Your response must be concise. -29.4. What is the difference between the Employment (as % of male employment) in Industry in 2007 and the Employment (as % of male employment) in Self-employed in 2009?
Offer a very short reply. 3. What is the difference between the Employment (as % of male employment) in Services in 2007 and the Employment (as % of male employment) in Self-employed in 2009?
Keep it short and to the point. 30.7. What is the average Employment (as % of male employment) of Agriculture per year?
Keep it short and to the point. 9.63. What is the average Employment (as % of male employment) of Industry per year?
Provide a short and direct response. 34.49. What is the average Employment (as % of male employment) of Services per year?
Your answer should be compact. 59.92. What is the average Employment (as % of male employment) in Self-employed per year?
Keep it short and to the point. 29.54. In the year 2000, what is the difference between the Employment (as % of male employment) in Agriculture and Employment (as % of male employment) in Industry?
Your answer should be compact. -33.1. In the year 2000, what is the difference between the Employment (as % of male employment) of Agriculture and Employment (as % of male employment) of Services?
Your response must be concise. -54.3. In the year 2000, what is the difference between the Employment (as % of male employment) in Agriculture and Employment (as % of male employment) in Self-employed?
Keep it short and to the point. -26.2. In the year 2000, what is the difference between the Employment (as % of male employment) of Industry and Employment (as % of male employment) of Services?
Ensure brevity in your answer.  -21.2. In the year 2000, what is the difference between the Employment (as % of male employment) of Services and Employment (as % of male employment) of Self-employed?
Offer a terse response. 28.1. In the year 2001, what is the difference between the Employment (as % of male employment) of Agriculture and Employment (as % of male employment) of Industry?
Ensure brevity in your answer.  -29.7. In the year 2001, what is the difference between the Employment (as % of male employment) of Agriculture and Employment (as % of male employment) of Services?
Give a very brief answer. -51.1. In the year 2001, what is the difference between the Employment (as % of male employment) in Agriculture and Employment (as % of male employment) in Self-employed?
Your answer should be compact. -26.2. In the year 2001, what is the difference between the Employment (as % of male employment) in Industry and Employment (as % of male employment) in Services?
Offer a terse response. -21.4. In the year 2001, what is the difference between the Employment (as % of male employment) in Services and Employment (as % of male employment) in Self-employed?
Provide a succinct answer. 24.9. In the year 2002, what is the difference between the Employment (as % of male employment) of Agriculture and Employment (as % of male employment) of Industry?
Provide a short and direct response. -29.6. In the year 2002, what is the difference between the Employment (as % of male employment) of Agriculture and Employment (as % of male employment) of Services?
Ensure brevity in your answer.  -51.6. In the year 2002, what is the difference between the Employment (as % of male employment) in Agriculture and Employment (as % of male employment) in Self-employed?
Give a very brief answer. -25.8. In the year 2002, what is the difference between the Employment (as % of male employment) in Industry and Employment (as % of male employment) in Services?
Your answer should be compact. -22. In the year 2002, what is the difference between the Employment (as % of male employment) in Industry and Employment (as % of male employment) in Self-employed?
Provide a short and direct response. 3.8. In the year 2002, what is the difference between the Employment (as % of male employment) in Services and Employment (as % of male employment) in Self-employed?
Your answer should be compact. 25.8. In the year 2003, what is the difference between the Employment (as % of male employment) of Agriculture and Employment (as % of male employment) of Industry?
Keep it short and to the point. -28.2. In the year 2003, what is the difference between the Employment (as % of male employment) of Agriculture and Employment (as % of male employment) of Services?
Offer a terse response. -52.2. In the year 2003, what is the difference between the Employment (as % of male employment) of Agriculture and Employment (as % of male employment) of Self-employed?
Your answer should be very brief. -18.5. In the year 2003, what is the difference between the Employment (as % of male employment) in Services and Employment (as % of male employment) in Self-employed?
Keep it short and to the point. 33.7. In the year 2004, what is the difference between the Employment (as % of male employment) in Agriculture and Employment (as % of male employment) in Industry?
Make the answer very short. -26.3. In the year 2004, what is the difference between the Employment (as % of male employment) in Agriculture and Employment (as % of male employment) in Services?
Provide a succinct answer. -51.9. In the year 2004, what is the difference between the Employment (as % of male employment) of Agriculture and Employment (as % of male employment) of Self-employed?
Provide a short and direct response. -17.6. In the year 2004, what is the difference between the Employment (as % of male employment) in Industry and Employment (as % of male employment) in Services?
Offer a terse response. -25.6. In the year 2004, what is the difference between the Employment (as % of male employment) of Services and Employment (as % of male employment) of Self-employed?
Provide a short and direct response. 34.3. In the year 2005, what is the difference between the Employment (as % of male employment) of Agriculture and Employment (as % of male employment) of Industry?
Your answer should be compact. -25.5. In the year 2005, what is the difference between the Employment (as % of male employment) of Agriculture and Employment (as % of male employment) of Services?
Ensure brevity in your answer.  -54.6. In the year 2005, what is the difference between the Employment (as % of male employment) in Agriculture and Employment (as % of male employment) in Self-employed?
Make the answer very short. -22.1. In the year 2005, what is the difference between the Employment (as % of male employment) of Industry and Employment (as % of male employment) of Services?
Your response must be concise. -29.1. In the year 2005, what is the difference between the Employment (as % of male employment) in Industry and Employment (as % of male employment) in Self-employed?
Provide a succinct answer. 3.4. In the year 2005, what is the difference between the Employment (as % of male employment) of Services and Employment (as % of male employment) of Self-employed?
Provide a succinct answer. 32.5. In the year 2006, what is the difference between the Employment (as % of male employment) in Agriculture and Employment (as % of male employment) in Industry?
Keep it short and to the point. -18.2. In the year 2006, what is the difference between the Employment (as % of male employment) of Agriculture and Employment (as % of male employment) of Services?
Give a very brief answer. -45.2. In the year 2006, what is the difference between the Employment (as % of male employment) in Agriculture and Employment (as % of male employment) in Self-employed?
Provide a succinct answer. -14.8. In the year 2006, what is the difference between the Employment (as % of male employment) of Industry and Employment (as % of male employment) of Services?
Give a very brief answer. -27. In the year 2006, what is the difference between the Employment (as % of male employment) of Services and Employment (as % of male employment) of Self-employed?
Offer a terse response. 30.4. In the year 2007, what is the difference between the Employment (as % of male employment) of Agriculture and Employment (as % of male employment) of Industry?
Your answer should be compact. -17.4. In the year 2007, what is the difference between the Employment (as % of male employment) in Agriculture and Employment (as % of male employment) in Services?
Provide a succinct answer. -45.1. In the year 2007, what is the difference between the Employment (as % of male employment) in Agriculture and Employment (as % of male employment) in Self-employed?
Your response must be concise. -13.8. In the year 2007, what is the difference between the Employment (as % of male employment) of Industry and Employment (as % of male employment) of Services?
Keep it short and to the point. -27.7. In the year 2007, what is the difference between the Employment (as % of male employment) in Services and Employment (as % of male employment) in Self-employed?
Offer a terse response. 31.3. In the year 2009, what is the difference between the Employment (as % of male employment) in Agriculture and Employment (as % of male employment) in Industry?
Your answer should be compact. -15.7. In the year 2009, what is the difference between the Employment (as % of male employment) in Agriculture and Employment (as % of male employment) in Services?
Provide a succinct answer. -46.6. In the year 2009, what is the difference between the Employment (as % of male employment) in Agriculture and Employment (as % of male employment) in Self-employed?
Make the answer very short. -14.2. In the year 2009, what is the difference between the Employment (as % of male employment) of Industry and Employment (as % of male employment) of Services?
Your answer should be compact. -30.9. In the year 2009, what is the difference between the Employment (as % of male employment) of Services and Employment (as % of male employment) of Self-employed?
Keep it short and to the point. 32.4. What is the ratio of the Employment (as % of male employment) in Agriculture in 2000 to that in 2001?
Give a very brief answer. 1.02. What is the ratio of the Employment (as % of male employment) of Industry in 2000 to that in 2001?
Provide a short and direct response. 1.1. What is the ratio of the Employment (as % of male employment) in Services in 2000 to that in 2001?
Your response must be concise. 1.06. What is the ratio of the Employment (as % of male employment) of Self-employed in 2000 to that in 2001?
Your answer should be very brief. 1. What is the ratio of the Employment (as % of male employment) in Agriculture in 2000 to that in 2002?
Provide a succinct answer. 0.97. What is the ratio of the Employment (as % of male employment) of Industry in 2000 to that in 2002?
Make the answer very short. 1.09. What is the ratio of the Employment (as % of male employment) of Services in 2000 to that in 2002?
Your answer should be compact. 1.04. What is the ratio of the Employment (as % of male employment) in Self-employed in 2000 to that in 2002?
Ensure brevity in your answer.  1.01. What is the ratio of the Employment (as % of male employment) of Agriculture in 2000 to that in 2003?
Give a very brief answer. 0.93. What is the ratio of the Employment (as % of male employment) of Industry in 2000 to that in 2003?
Your answer should be very brief. 1.13. What is the ratio of the Employment (as % of male employment) in Services in 2000 to that in 2003?
Your answer should be very brief. 1.03. What is the ratio of the Employment (as % of male employment) of Agriculture in 2000 to that in 2004?
Keep it short and to the point. 0.84. What is the ratio of the Employment (as % of male employment) in Industry in 2000 to that in 2004?
Provide a short and direct response. 1.17. What is the ratio of the Employment (as % of male employment) of Services in 2000 to that in 2004?
Provide a short and direct response. 1.02. What is the ratio of the Employment (as % of male employment) in Self-employed in 2000 to that in 2004?
Keep it short and to the point. 1.3. What is the ratio of the Employment (as % of male employment) in Agriculture in 2000 to that in 2005?
Your answer should be very brief. 0.87. What is the ratio of the Employment (as % of male employment) of Industry in 2000 to that in 2005?
Your response must be concise. 1.21. What is the ratio of the Employment (as % of male employment) in Services in 2000 to that in 2005?
Your response must be concise. 0.98. What is the ratio of the Employment (as % of male employment) of Self-employed in 2000 to that in 2005?
Ensure brevity in your answer.  1.11. What is the ratio of the Employment (as % of male employment) in Agriculture in 2000 to that in 2006?
Offer a terse response. 0.4. What is the ratio of the Employment (as % of male employment) of Industry in 2000 to that in 2006?
Give a very brief answer. 1.17. What is the ratio of the Employment (as % of male employment) of Self-employed in 2000 to that in 2006?
Your answer should be compact. 1.07. What is the ratio of the Employment (as % of male employment) of Agriculture in 2000 to that in 2007?
Ensure brevity in your answer.  0.4. What is the ratio of the Employment (as % of male employment) of Industry in 2000 to that in 2007?
Your answer should be very brief. 1.19. What is the ratio of the Employment (as % of male employment) in Self-employed in 2000 to that in 2007?
Ensure brevity in your answer.  1.1. What is the ratio of the Employment (as % of male employment) of Agriculture in 2000 to that in 2009?
Give a very brief answer. 0.39. What is the ratio of the Employment (as % of male employment) in Industry in 2000 to that in 2009?
Keep it short and to the point. 1.25. What is the ratio of the Employment (as % of male employment) of Services in 2000 to that in 2009?
Your answer should be very brief. 0.97. What is the ratio of the Employment (as % of male employment) of Self-employed in 2000 to that in 2009?
Ensure brevity in your answer.  1.08. What is the ratio of the Employment (as % of male employment) in Agriculture in 2001 to that in 2002?
Ensure brevity in your answer.  0.95. What is the ratio of the Employment (as % of male employment) of Industry in 2001 to that in 2002?
Provide a succinct answer. 0.99. What is the ratio of the Employment (as % of male employment) in Services in 2001 to that in 2002?
Offer a very short reply. 0.99. What is the ratio of the Employment (as % of male employment) of Self-employed in 2001 to that in 2002?
Offer a terse response. 1. What is the ratio of the Employment (as % of male employment) of Agriculture in 2001 to that in 2003?
Give a very brief answer. 0.91. What is the ratio of the Employment (as % of male employment) of Industry in 2001 to that in 2003?
Your response must be concise. 1.03. What is the ratio of the Employment (as % of male employment) in Services in 2001 to that in 2003?
Ensure brevity in your answer.  0.97. What is the ratio of the Employment (as % of male employment) of Self-employed in 2001 to that in 2003?
Keep it short and to the point. 1.28. What is the ratio of the Employment (as % of male employment) in Agriculture in 2001 to that in 2004?
Your response must be concise. 0.82. What is the ratio of the Employment (as % of male employment) in Industry in 2001 to that in 2004?
Offer a terse response. 1.06. What is the ratio of the Employment (as % of male employment) of Services in 2001 to that in 2004?
Ensure brevity in your answer.  0.96. What is the ratio of the Employment (as % of male employment) of Self-employed in 2001 to that in 2004?
Provide a succinct answer. 1.29. What is the ratio of the Employment (as % of male employment) in Agriculture in 2001 to that in 2005?
Provide a succinct answer. 0.86. What is the ratio of the Employment (as % of male employment) in Industry in 2001 to that in 2005?
Offer a very short reply. 1.1. What is the ratio of the Employment (as % of male employment) of Services in 2001 to that in 2005?
Keep it short and to the point. 0.93. What is the ratio of the Employment (as % of male employment) of Self-employed in 2001 to that in 2005?
Your answer should be very brief. 1.11. What is the ratio of the Employment (as % of male employment) of Agriculture in 2001 to that in 2006?
Offer a terse response. 0.4. What is the ratio of the Employment (as % of male employment) in Industry in 2001 to that in 2006?
Make the answer very short. 1.07. What is the ratio of the Employment (as % of male employment) of Services in 2001 to that in 2006?
Keep it short and to the point. 0.94. What is the ratio of the Employment (as % of male employment) of Self-employed in 2001 to that in 2006?
Offer a very short reply. 1.07. What is the ratio of the Employment (as % of male employment) of Agriculture in 2001 to that in 2007?
Keep it short and to the point. 0.39. What is the ratio of the Employment (as % of male employment) of Industry in 2001 to that in 2007?
Offer a very short reply. 1.08. What is the ratio of the Employment (as % of male employment) of Services in 2001 to that in 2007?
Offer a terse response. 0.94. What is the ratio of the Employment (as % of male employment) of Self-employed in 2001 to that in 2007?
Offer a very short reply. 1.1. What is the ratio of the Employment (as % of male employment) of Agriculture in 2001 to that in 2009?
Your answer should be very brief. 0.39. What is the ratio of the Employment (as % of male employment) in Industry in 2001 to that in 2009?
Offer a terse response. 1.14. What is the ratio of the Employment (as % of male employment) in Self-employed in 2001 to that in 2009?
Make the answer very short. 1.08. What is the ratio of the Employment (as % of male employment) in Agriculture in 2002 to that in 2003?
Ensure brevity in your answer.  0.96. What is the ratio of the Employment (as % of male employment) of Industry in 2002 to that in 2003?
Your answer should be compact. 1.03. What is the ratio of the Employment (as % of male employment) in Services in 2002 to that in 2003?
Give a very brief answer. 0.98. What is the ratio of the Employment (as % of male employment) of Self-employed in 2002 to that in 2003?
Keep it short and to the point. 1.28. What is the ratio of the Employment (as % of male employment) of Agriculture in 2002 to that in 2004?
Make the answer very short. 0.86. What is the ratio of the Employment (as % of male employment) of Industry in 2002 to that in 2004?
Give a very brief answer. 1.07. What is the ratio of the Employment (as % of male employment) of Services in 2002 to that in 2004?
Provide a succinct answer. 0.98. What is the ratio of the Employment (as % of male employment) of Self-employed in 2002 to that in 2004?
Your answer should be compact. 1.29. What is the ratio of the Employment (as % of male employment) in Agriculture in 2002 to that in 2005?
Provide a short and direct response. 0.9. What is the ratio of the Employment (as % of male employment) in Industry in 2002 to that in 2005?
Your answer should be compact. 1.1. What is the ratio of the Employment (as % of male employment) in Self-employed in 2002 to that in 2005?
Your answer should be compact. 1.1. What is the ratio of the Employment (as % of male employment) of Agriculture in 2002 to that in 2006?
Offer a very short reply. 0.42. What is the ratio of the Employment (as % of male employment) of Industry in 2002 to that in 2006?
Provide a short and direct response. 1.07. What is the ratio of the Employment (as % of male employment) in Services in 2002 to that in 2006?
Offer a terse response. 0.96. What is the ratio of the Employment (as % of male employment) of Self-employed in 2002 to that in 2006?
Your answer should be very brief. 1.07. What is the ratio of the Employment (as % of male employment) of Agriculture in 2002 to that in 2007?
Your answer should be very brief. 0.41. What is the ratio of the Employment (as % of male employment) in Industry in 2002 to that in 2007?
Make the answer very short. 1.09. What is the ratio of the Employment (as % of male employment) in Services in 2002 to that in 2007?
Provide a short and direct response. 0.96. What is the ratio of the Employment (as % of male employment) of Self-employed in 2002 to that in 2007?
Provide a short and direct response. 1.1. What is the ratio of the Employment (as % of male employment) in Agriculture in 2002 to that in 2009?
Provide a succinct answer. 0.41. What is the ratio of the Employment (as % of male employment) in Services in 2002 to that in 2009?
Provide a short and direct response. 0.93. What is the ratio of the Employment (as % of male employment) in Self-employed in 2002 to that in 2009?
Your answer should be very brief. 1.07. What is the ratio of the Employment (as % of male employment) of Agriculture in 2003 to that in 2004?
Offer a terse response. 0.91. What is the ratio of the Employment (as % of male employment) of Industry in 2003 to that in 2004?
Ensure brevity in your answer.  1.04. What is the ratio of the Employment (as % of male employment) in Self-employed in 2003 to that in 2004?
Keep it short and to the point. 1.01. What is the ratio of the Employment (as % of male employment) in Agriculture in 2003 to that in 2005?
Make the answer very short. 0.94. What is the ratio of the Employment (as % of male employment) in Industry in 2003 to that in 2005?
Give a very brief answer. 1.07. What is the ratio of the Employment (as % of male employment) in Services in 2003 to that in 2005?
Make the answer very short. 0.95. What is the ratio of the Employment (as % of male employment) of Self-employed in 2003 to that in 2005?
Give a very brief answer. 0.86. What is the ratio of the Employment (as % of male employment) of Agriculture in 2003 to that in 2006?
Your response must be concise. 0.44. What is the ratio of the Employment (as % of male employment) of Industry in 2003 to that in 2006?
Provide a short and direct response. 1.04. What is the ratio of the Employment (as % of male employment) in Services in 2003 to that in 2006?
Your response must be concise. 0.97. What is the ratio of the Employment (as % of male employment) of Self-employed in 2003 to that in 2006?
Make the answer very short. 0.83. What is the ratio of the Employment (as % of male employment) of Agriculture in 2003 to that in 2007?
Offer a very short reply. 0.43. What is the ratio of the Employment (as % of male employment) of Industry in 2003 to that in 2007?
Keep it short and to the point. 1.06. What is the ratio of the Employment (as % of male employment) of Services in 2003 to that in 2007?
Your answer should be very brief. 0.97. What is the ratio of the Employment (as % of male employment) in Agriculture in 2003 to that in 2009?
Provide a succinct answer. 0.42. What is the ratio of the Employment (as % of male employment) of Industry in 2003 to that in 2009?
Ensure brevity in your answer.  1.11. What is the ratio of the Employment (as % of male employment) in Services in 2003 to that in 2009?
Your answer should be compact. 0.94. What is the ratio of the Employment (as % of male employment) of Self-employed in 2003 to that in 2009?
Give a very brief answer. 0.84. What is the ratio of the Employment (as % of male employment) of Agriculture in 2004 to that in 2005?
Make the answer very short. 1.04. What is the ratio of the Employment (as % of male employment) in Industry in 2004 to that in 2005?
Make the answer very short. 1.03. What is the ratio of the Employment (as % of male employment) of Services in 2004 to that in 2005?
Provide a succinct answer. 0.96. What is the ratio of the Employment (as % of male employment) in Self-employed in 2004 to that in 2005?
Make the answer very short. 0.86. What is the ratio of the Employment (as % of male employment) in Agriculture in 2004 to that in 2006?
Offer a very short reply. 0.48. What is the ratio of the Employment (as % of male employment) in Industry in 2004 to that in 2006?
Offer a terse response. 1. What is the ratio of the Employment (as % of male employment) in Services in 2004 to that in 2006?
Offer a terse response. 0.98. What is the ratio of the Employment (as % of male employment) of Self-employed in 2004 to that in 2006?
Offer a very short reply. 0.83. What is the ratio of the Employment (as % of male employment) in Agriculture in 2004 to that in 2007?
Offer a very short reply. 0.47. What is the ratio of the Employment (as % of male employment) in Industry in 2004 to that in 2007?
Keep it short and to the point. 1.02. What is the ratio of the Employment (as % of male employment) in Services in 2004 to that in 2007?
Provide a succinct answer. 0.98. What is the ratio of the Employment (as % of male employment) in Self-employed in 2004 to that in 2007?
Make the answer very short. 0.85. What is the ratio of the Employment (as % of male employment) in Agriculture in 2004 to that in 2009?
Give a very brief answer. 0.47. What is the ratio of the Employment (as % of male employment) in Industry in 2004 to that in 2009?
Ensure brevity in your answer.  1.07. What is the ratio of the Employment (as % of male employment) in Services in 2004 to that in 2009?
Offer a very short reply. 0.95. What is the ratio of the Employment (as % of male employment) of Self-employed in 2004 to that in 2009?
Give a very brief answer. 0.83. What is the ratio of the Employment (as % of male employment) in Agriculture in 2005 to that in 2006?
Provide a succinct answer. 0.46. What is the ratio of the Employment (as % of male employment) of Industry in 2005 to that in 2006?
Provide a succinct answer. 0.97. What is the ratio of the Employment (as % of male employment) of Services in 2005 to that in 2006?
Provide a short and direct response. 1.02. What is the ratio of the Employment (as % of male employment) of Self-employed in 2005 to that in 2006?
Provide a succinct answer. 0.97. What is the ratio of the Employment (as % of male employment) in Agriculture in 2005 to that in 2007?
Provide a short and direct response. 0.46. What is the ratio of the Employment (as % of male employment) of Industry in 2005 to that in 2007?
Keep it short and to the point. 0.99. What is the ratio of the Employment (as % of male employment) in Services in 2005 to that in 2007?
Your response must be concise. 1.02. What is the ratio of the Employment (as % of male employment) of Agriculture in 2005 to that in 2009?
Your answer should be compact. 0.45. What is the ratio of the Employment (as % of male employment) of Industry in 2005 to that in 2009?
Offer a terse response. 1.03. What is the ratio of the Employment (as % of male employment) of Services in 2005 to that in 2009?
Your answer should be very brief. 0.99. What is the ratio of the Employment (as % of male employment) in Self-employed in 2005 to that in 2009?
Keep it short and to the point. 0.97. What is the ratio of the Employment (as % of male employment) in Agriculture in 2006 to that in 2007?
Make the answer very short. 0.99. What is the ratio of the Employment (as % of male employment) in Industry in 2006 to that in 2007?
Offer a very short reply. 1.02. What is the ratio of the Employment (as % of male employment) of Self-employed in 2006 to that in 2007?
Give a very brief answer. 1.03. What is the ratio of the Employment (as % of male employment) in Agriculture in 2006 to that in 2009?
Your answer should be compact. 0.97. What is the ratio of the Employment (as % of male employment) in Industry in 2006 to that in 2009?
Provide a short and direct response. 1.07. What is the ratio of the Employment (as % of male employment) in Services in 2006 to that in 2009?
Offer a terse response. 0.97. What is the ratio of the Employment (as % of male employment) in Self-employed in 2006 to that in 2009?
Make the answer very short. 1.01. What is the ratio of the Employment (as % of male employment) in Agriculture in 2007 to that in 2009?
Your answer should be compact. 0.99. What is the ratio of the Employment (as % of male employment) in Industry in 2007 to that in 2009?
Your answer should be compact. 1.05. What is the ratio of the Employment (as % of male employment) of Services in 2007 to that in 2009?
Keep it short and to the point. 0.97. What is the difference between the highest and the second highest Employment (as % of male employment) of Agriculture?
Provide a succinct answer. 0.2. What is the difference between the highest and the second highest Employment (as % of male employment) of Industry?
Provide a short and direct response. 3.3. What is the difference between the highest and the second highest Employment (as % of male employment) of Services?
Keep it short and to the point. 0.7. What is the difference between the highest and the lowest Employment (as % of male employment) in Agriculture?
Offer a terse response. 9.7. What is the difference between the highest and the lowest Employment (as % of male employment) in Services?
Offer a terse response. 5.2. What is the difference between the highest and the lowest Employment (as % of male employment) in Self-employed?
Your response must be concise. 7.4. 